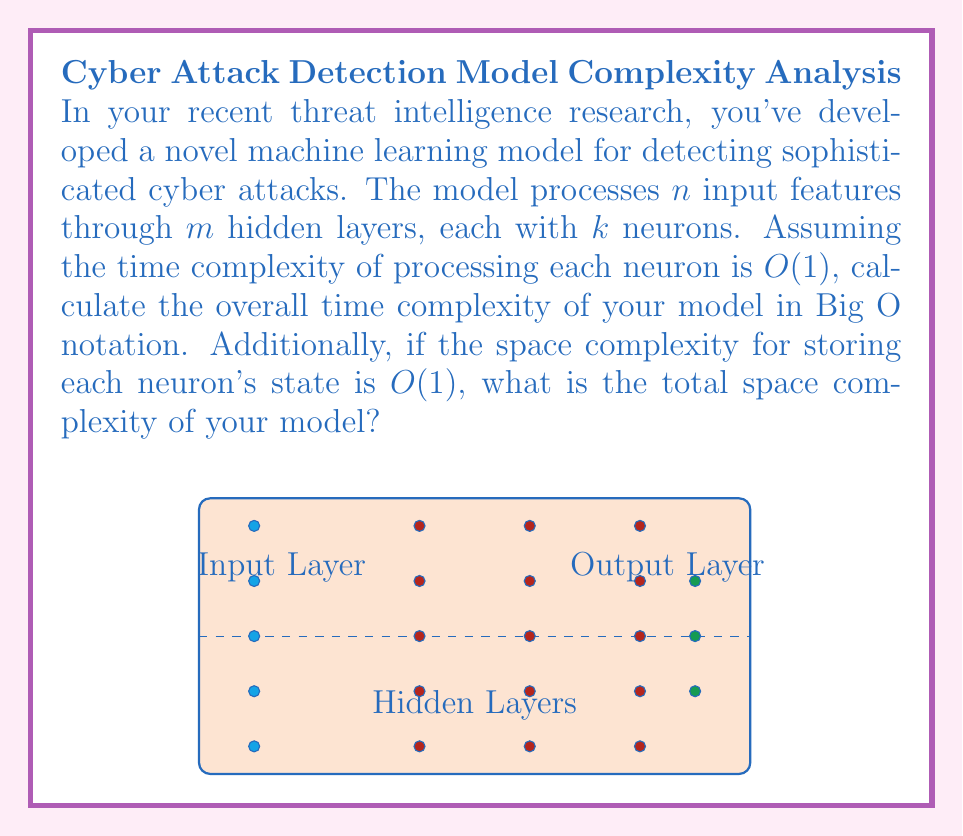What is the answer to this math problem? Let's break this down step-by-step:

1. Time Complexity:
   a. The input layer processes $n$ features.
   b. There are $m$ hidden layers, each with $k$ neurons.
   c. Each neuron takes $O(1)$ time to process.
   d. For each layer, we process $k$ neurons.
   e. We do this for all $m$ layers.
   f. Therefore, the time complexity is: $O(n + m * k)$
      (We add $n$ for the initial input processing)

2. Space Complexity:
   a. We need to store the state of each neuron.
   b. There are $k$ neurons in each of the $m$ hidden layers.
   c. Each neuron's state takes $O(1)$ space.
   d. We also need to account for the $n$ input features and the output layer (which typically has fewer neurons than hidden layers, so we can consider it negligible compared to $m * k$).
   e. Therefore, the space complexity is: $O(n + m * k)$

3. Simplification:
   In most practical scenarios, the number of features ($n$) and the number of neurons per layer ($k$) are significantly larger than the number of layers ($m$). Therefore, we can simplify our complexity to:
   $O(n + m * k) \approx O(\max(n, m * k))$

   This simplification holds true for both time and space complexity in this case.
Answer: Time Complexity: $O(\max(n, m * k))$
Space Complexity: $O(\max(n, m * k))$ 